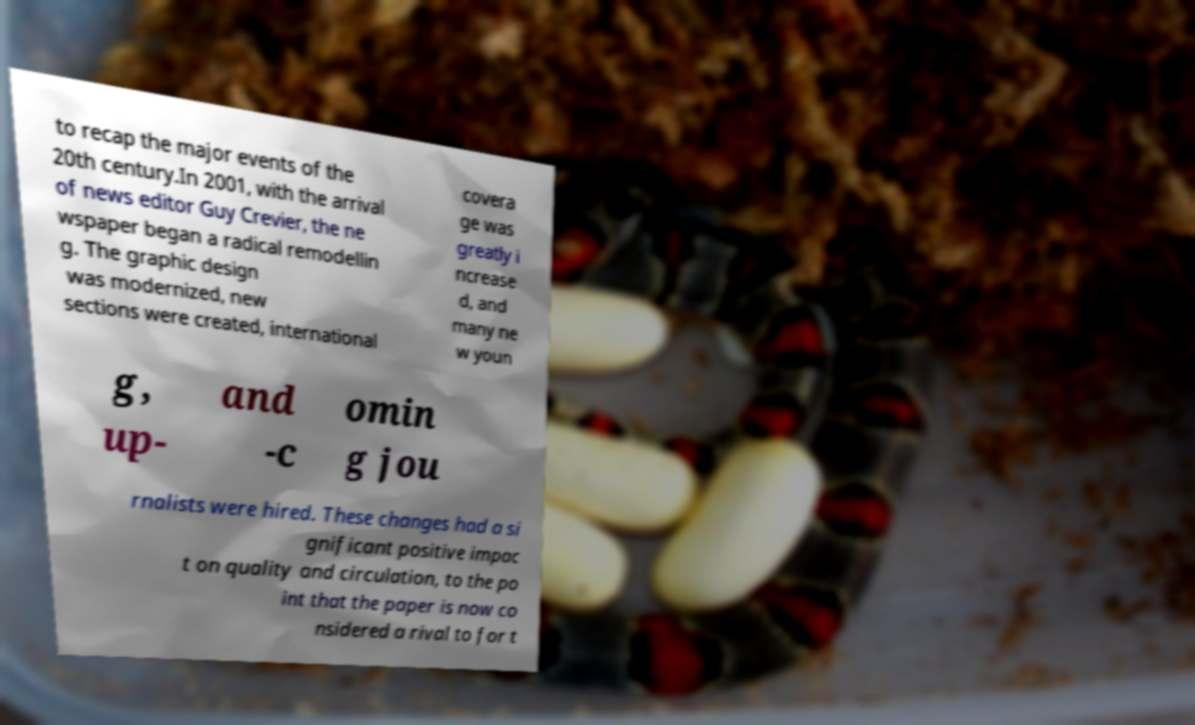Please read and relay the text visible in this image. What does it say? to recap the major events of the 20th century.In 2001, with the arrival of news editor Guy Crevier, the ne wspaper began a radical remodellin g. The graphic design was modernized, new sections were created, international covera ge was greatly i ncrease d, and many ne w youn g, up- and -c omin g jou rnalists were hired. These changes had a si gnificant positive impac t on quality and circulation, to the po int that the paper is now co nsidered a rival to for t 